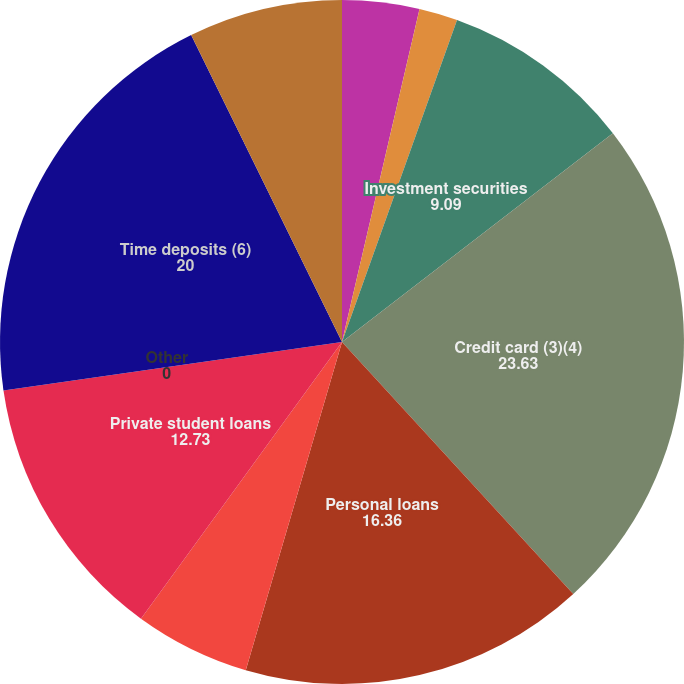Convert chart to OTSL. <chart><loc_0><loc_0><loc_500><loc_500><pie_chart><fcel>Cash and cash equivalents<fcel>Restricted cash<fcel>Investment securities<fcel>Credit card (3)(4)<fcel>Personal loans<fcel>Federal student loans (5)<fcel>Private student loans<fcel>Other<fcel>Time deposits (6)<fcel>Money market deposits<nl><fcel>3.64%<fcel>1.82%<fcel>9.09%<fcel>23.63%<fcel>16.36%<fcel>5.46%<fcel>12.73%<fcel>0.0%<fcel>20.0%<fcel>7.27%<nl></chart> 